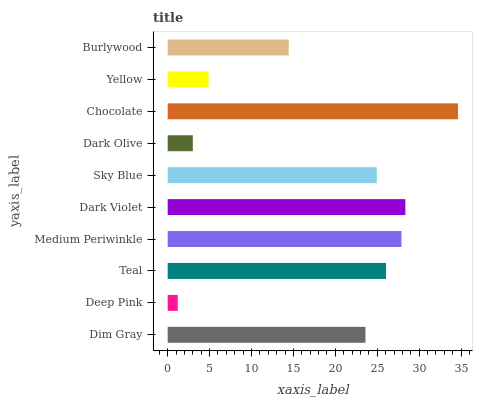Is Deep Pink the minimum?
Answer yes or no. Yes. Is Chocolate the maximum?
Answer yes or no. Yes. Is Teal the minimum?
Answer yes or no. No. Is Teal the maximum?
Answer yes or no. No. Is Teal greater than Deep Pink?
Answer yes or no. Yes. Is Deep Pink less than Teal?
Answer yes or no. Yes. Is Deep Pink greater than Teal?
Answer yes or no. No. Is Teal less than Deep Pink?
Answer yes or no. No. Is Sky Blue the high median?
Answer yes or no. Yes. Is Dim Gray the low median?
Answer yes or no. Yes. Is Burlywood the high median?
Answer yes or no. No. Is Dark Olive the low median?
Answer yes or no. No. 